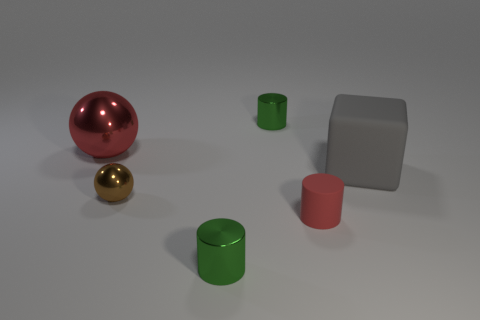What could be the possible use of these objects? The objects might be used for various purposes, potentially as geometric shape samples for educational use, decorative pieces, or as part of a still life arrangement for artistic purposes such as a painting or photography setup. Could they have any functional purpose in everyday life? While these objects could serve a decorative purpose, they don't seem to have any immediate functional use in everyday life as presented. However, if they were containers, the cylindrical and cubic shapes could be used to hold small items. 